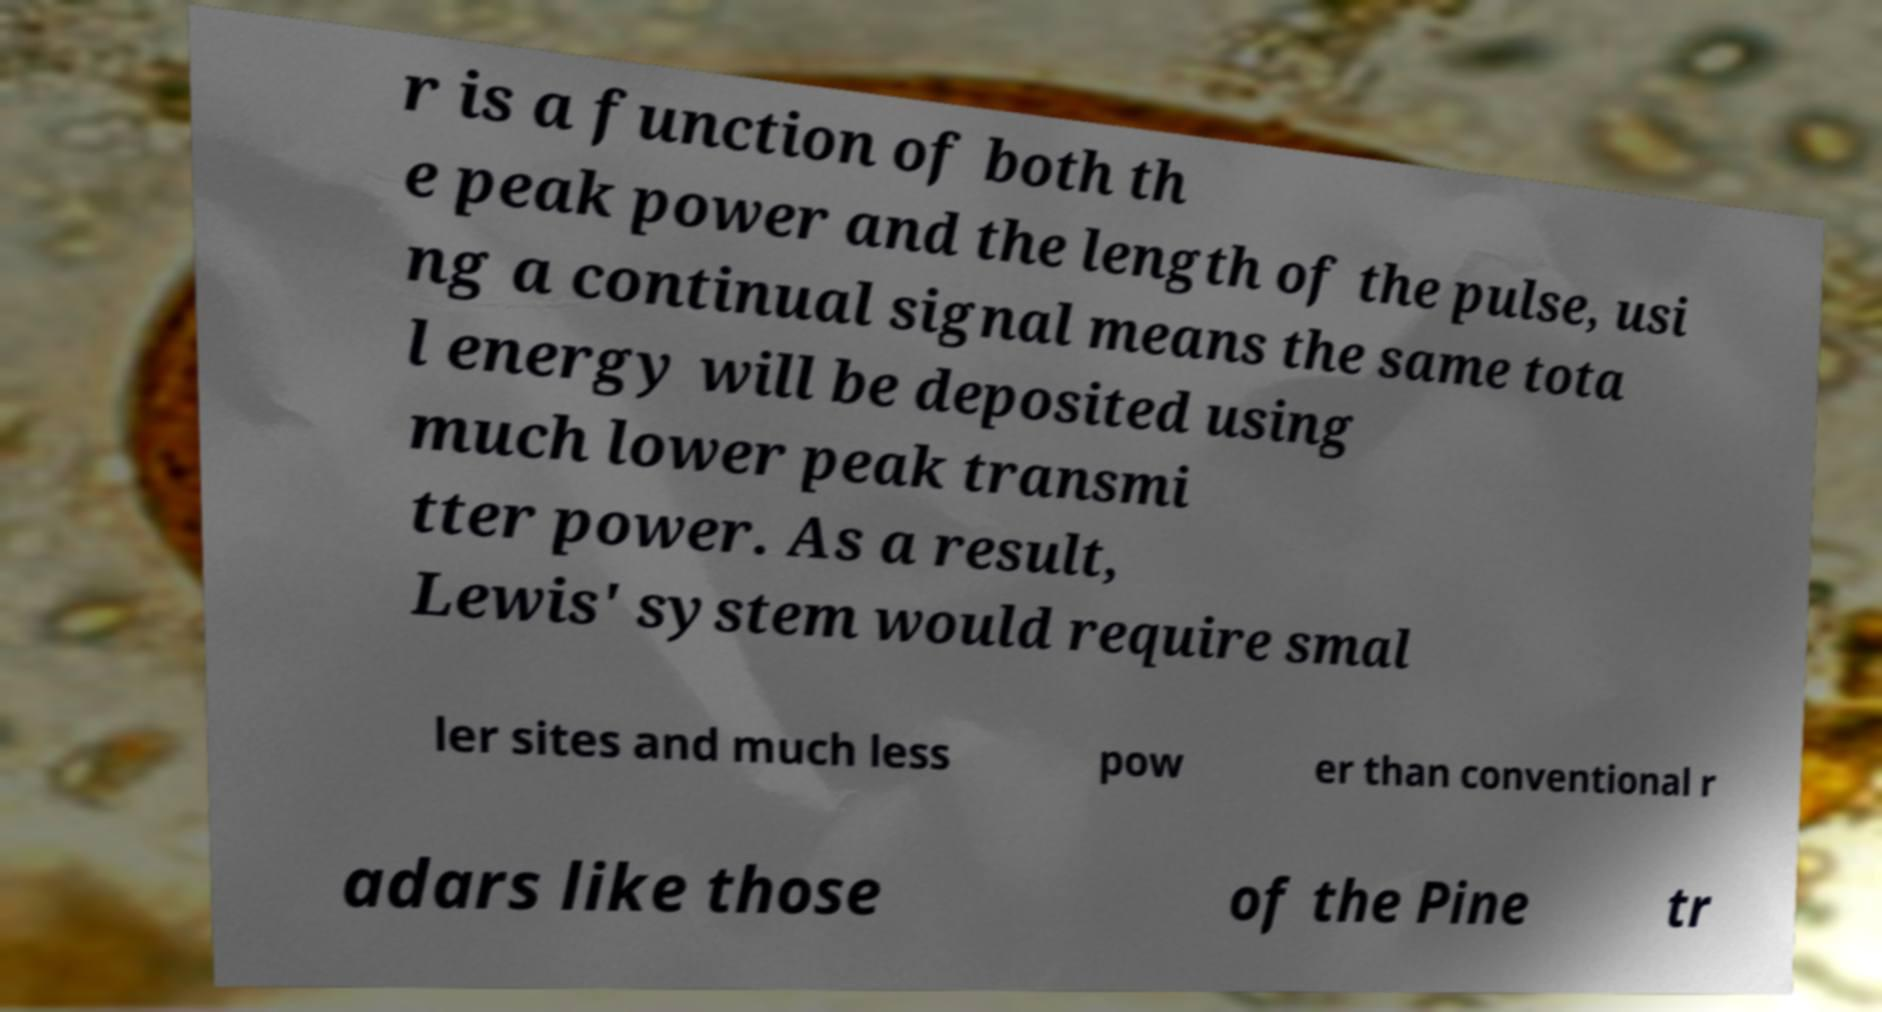For documentation purposes, I need the text within this image transcribed. Could you provide that? r is a function of both th e peak power and the length of the pulse, usi ng a continual signal means the same tota l energy will be deposited using much lower peak transmi tter power. As a result, Lewis' system would require smal ler sites and much less pow er than conventional r adars like those of the Pine tr 